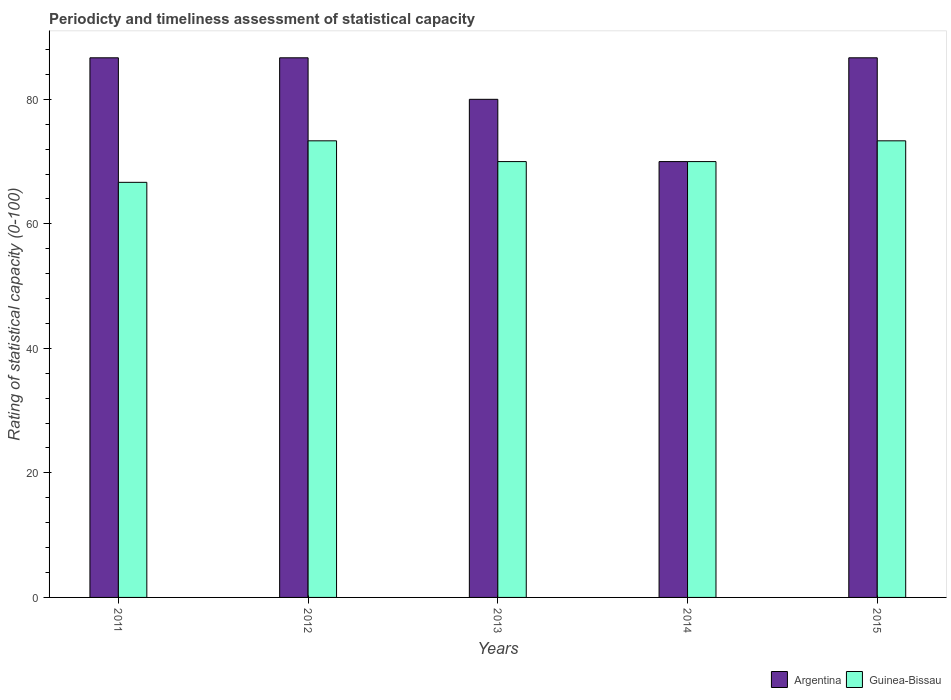How many different coloured bars are there?
Offer a very short reply. 2. How many bars are there on the 3rd tick from the right?
Provide a short and direct response. 2. What is the rating of statistical capacity in Argentina in 2012?
Offer a very short reply. 86.67. Across all years, what is the maximum rating of statistical capacity in Argentina?
Provide a short and direct response. 86.67. What is the total rating of statistical capacity in Argentina in the graph?
Offer a very short reply. 410. What is the difference between the rating of statistical capacity in Guinea-Bissau in 2014 and that in 2015?
Provide a succinct answer. -3.33. What is the difference between the rating of statistical capacity in Argentina in 2011 and the rating of statistical capacity in Guinea-Bissau in 2015?
Provide a short and direct response. 13.33. What is the average rating of statistical capacity in Argentina per year?
Offer a very short reply. 82. In the year 2012, what is the difference between the rating of statistical capacity in Guinea-Bissau and rating of statistical capacity in Argentina?
Give a very brief answer. -13.33. In how many years, is the rating of statistical capacity in Guinea-Bissau greater than 28?
Provide a succinct answer. 5. What is the ratio of the rating of statistical capacity in Guinea-Bissau in 2011 to that in 2015?
Keep it short and to the point. 0.91. Is the rating of statistical capacity in Guinea-Bissau in 2011 less than that in 2013?
Give a very brief answer. Yes. Is the difference between the rating of statistical capacity in Guinea-Bissau in 2011 and 2013 greater than the difference between the rating of statistical capacity in Argentina in 2011 and 2013?
Offer a terse response. No. What is the difference between the highest and the second highest rating of statistical capacity in Argentina?
Provide a succinct answer. 3.000000000952241e-5. What is the difference between the highest and the lowest rating of statistical capacity in Guinea-Bissau?
Offer a terse response. 6.67. In how many years, is the rating of statistical capacity in Argentina greater than the average rating of statistical capacity in Argentina taken over all years?
Keep it short and to the point. 3. Is the sum of the rating of statistical capacity in Argentina in 2013 and 2015 greater than the maximum rating of statistical capacity in Guinea-Bissau across all years?
Give a very brief answer. Yes. What does the 2nd bar from the right in 2011 represents?
Make the answer very short. Argentina. How many bars are there?
Your response must be concise. 10. What is the difference between two consecutive major ticks on the Y-axis?
Your answer should be very brief. 20. Are the values on the major ticks of Y-axis written in scientific E-notation?
Your answer should be compact. No. Where does the legend appear in the graph?
Your response must be concise. Bottom right. What is the title of the graph?
Ensure brevity in your answer.  Periodicty and timeliness assessment of statistical capacity. Does "Peru" appear as one of the legend labels in the graph?
Provide a short and direct response. No. What is the label or title of the X-axis?
Your answer should be very brief. Years. What is the label or title of the Y-axis?
Offer a terse response. Rating of statistical capacity (0-100). What is the Rating of statistical capacity (0-100) in Argentina in 2011?
Give a very brief answer. 86.67. What is the Rating of statistical capacity (0-100) of Guinea-Bissau in 2011?
Give a very brief answer. 66.67. What is the Rating of statistical capacity (0-100) of Argentina in 2012?
Make the answer very short. 86.67. What is the Rating of statistical capacity (0-100) in Guinea-Bissau in 2012?
Your answer should be very brief. 73.33. What is the Rating of statistical capacity (0-100) in Argentina in 2013?
Offer a terse response. 80. What is the Rating of statistical capacity (0-100) of Argentina in 2014?
Give a very brief answer. 70. What is the Rating of statistical capacity (0-100) of Argentina in 2015?
Offer a terse response. 86.67. What is the Rating of statistical capacity (0-100) of Guinea-Bissau in 2015?
Offer a terse response. 73.33. Across all years, what is the maximum Rating of statistical capacity (0-100) of Argentina?
Provide a succinct answer. 86.67. Across all years, what is the maximum Rating of statistical capacity (0-100) of Guinea-Bissau?
Ensure brevity in your answer.  73.33. Across all years, what is the minimum Rating of statistical capacity (0-100) of Argentina?
Your answer should be compact. 70. Across all years, what is the minimum Rating of statistical capacity (0-100) in Guinea-Bissau?
Make the answer very short. 66.67. What is the total Rating of statistical capacity (0-100) of Argentina in the graph?
Ensure brevity in your answer.  410. What is the total Rating of statistical capacity (0-100) in Guinea-Bissau in the graph?
Your answer should be very brief. 353.33. What is the difference between the Rating of statistical capacity (0-100) in Guinea-Bissau in 2011 and that in 2012?
Your response must be concise. -6.67. What is the difference between the Rating of statistical capacity (0-100) in Argentina in 2011 and that in 2013?
Your answer should be very brief. 6.67. What is the difference between the Rating of statistical capacity (0-100) in Argentina in 2011 and that in 2014?
Give a very brief answer. 16.67. What is the difference between the Rating of statistical capacity (0-100) of Guinea-Bissau in 2011 and that in 2015?
Give a very brief answer. -6.67. What is the difference between the Rating of statistical capacity (0-100) in Guinea-Bissau in 2012 and that in 2013?
Offer a terse response. 3.33. What is the difference between the Rating of statistical capacity (0-100) in Argentina in 2012 and that in 2014?
Your answer should be very brief. 16.67. What is the difference between the Rating of statistical capacity (0-100) of Guinea-Bissau in 2012 and that in 2014?
Your answer should be compact. 3.33. What is the difference between the Rating of statistical capacity (0-100) in Guinea-Bissau in 2012 and that in 2015?
Offer a terse response. 0. What is the difference between the Rating of statistical capacity (0-100) of Argentina in 2013 and that in 2015?
Make the answer very short. -6.67. What is the difference between the Rating of statistical capacity (0-100) of Argentina in 2014 and that in 2015?
Provide a succinct answer. -16.67. What is the difference between the Rating of statistical capacity (0-100) of Guinea-Bissau in 2014 and that in 2015?
Offer a very short reply. -3.33. What is the difference between the Rating of statistical capacity (0-100) of Argentina in 2011 and the Rating of statistical capacity (0-100) of Guinea-Bissau in 2012?
Your response must be concise. 13.33. What is the difference between the Rating of statistical capacity (0-100) of Argentina in 2011 and the Rating of statistical capacity (0-100) of Guinea-Bissau in 2013?
Make the answer very short. 16.67. What is the difference between the Rating of statistical capacity (0-100) in Argentina in 2011 and the Rating of statistical capacity (0-100) in Guinea-Bissau in 2014?
Provide a succinct answer. 16.67. What is the difference between the Rating of statistical capacity (0-100) in Argentina in 2011 and the Rating of statistical capacity (0-100) in Guinea-Bissau in 2015?
Keep it short and to the point. 13.33. What is the difference between the Rating of statistical capacity (0-100) in Argentina in 2012 and the Rating of statistical capacity (0-100) in Guinea-Bissau in 2013?
Ensure brevity in your answer.  16.67. What is the difference between the Rating of statistical capacity (0-100) of Argentina in 2012 and the Rating of statistical capacity (0-100) of Guinea-Bissau in 2014?
Your answer should be very brief. 16.67. What is the difference between the Rating of statistical capacity (0-100) in Argentina in 2012 and the Rating of statistical capacity (0-100) in Guinea-Bissau in 2015?
Ensure brevity in your answer.  13.33. What is the difference between the Rating of statistical capacity (0-100) of Argentina in 2013 and the Rating of statistical capacity (0-100) of Guinea-Bissau in 2015?
Make the answer very short. 6.67. What is the difference between the Rating of statistical capacity (0-100) of Argentina in 2014 and the Rating of statistical capacity (0-100) of Guinea-Bissau in 2015?
Your answer should be very brief. -3.33. What is the average Rating of statistical capacity (0-100) in Guinea-Bissau per year?
Offer a very short reply. 70.67. In the year 2012, what is the difference between the Rating of statistical capacity (0-100) in Argentina and Rating of statistical capacity (0-100) in Guinea-Bissau?
Provide a short and direct response. 13.33. In the year 2013, what is the difference between the Rating of statistical capacity (0-100) of Argentina and Rating of statistical capacity (0-100) of Guinea-Bissau?
Offer a terse response. 10. In the year 2015, what is the difference between the Rating of statistical capacity (0-100) in Argentina and Rating of statistical capacity (0-100) in Guinea-Bissau?
Keep it short and to the point. 13.33. What is the ratio of the Rating of statistical capacity (0-100) in Argentina in 2011 to that in 2012?
Make the answer very short. 1. What is the ratio of the Rating of statistical capacity (0-100) of Guinea-Bissau in 2011 to that in 2012?
Give a very brief answer. 0.91. What is the ratio of the Rating of statistical capacity (0-100) of Argentina in 2011 to that in 2013?
Your answer should be compact. 1.08. What is the ratio of the Rating of statistical capacity (0-100) of Argentina in 2011 to that in 2014?
Ensure brevity in your answer.  1.24. What is the ratio of the Rating of statistical capacity (0-100) in Guinea-Bissau in 2011 to that in 2014?
Ensure brevity in your answer.  0.95. What is the ratio of the Rating of statistical capacity (0-100) in Argentina in 2012 to that in 2013?
Provide a succinct answer. 1.08. What is the ratio of the Rating of statistical capacity (0-100) in Guinea-Bissau in 2012 to that in 2013?
Provide a short and direct response. 1.05. What is the ratio of the Rating of statistical capacity (0-100) in Argentina in 2012 to that in 2014?
Make the answer very short. 1.24. What is the ratio of the Rating of statistical capacity (0-100) of Guinea-Bissau in 2012 to that in 2014?
Offer a terse response. 1.05. What is the ratio of the Rating of statistical capacity (0-100) of Argentina in 2012 to that in 2015?
Ensure brevity in your answer.  1. What is the ratio of the Rating of statistical capacity (0-100) in Guinea-Bissau in 2013 to that in 2014?
Your answer should be compact. 1. What is the ratio of the Rating of statistical capacity (0-100) of Argentina in 2013 to that in 2015?
Your response must be concise. 0.92. What is the ratio of the Rating of statistical capacity (0-100) in Guinea-Bissau in 2013 to that in 2015?
Give a very brief answer. 0.95. What is the ratio of the Rating of statistical capacity (0-100) of Argentina in 2014 to that in 2015?
Ensure brevity in your answer.  0.81. What is the ratio of the Rating of statistical capacity (0-100) in Guinea-Bissau in 2014 to that in 2015?
Keep it short and to the point. 0.95. What is the difference between the highest and the lowest Rating of statistical capacity (0-100) of Argentina?
Your response must be concise. 16.67. What is the difference between the highest and the lowest Rating of statistical capacity (0-100) in Guinea-Bissau?
Keep it short and to the point. 6.67. 